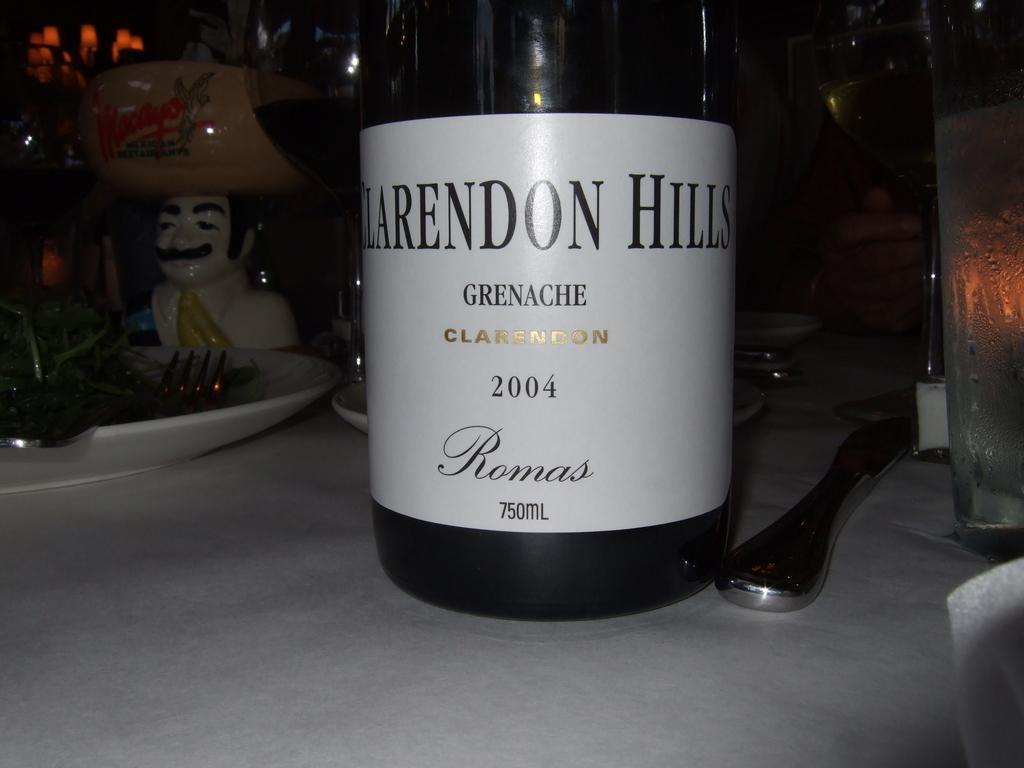Please provide a concise description of this image. In this image we can see bottles, plates, knife, forks and a toy on the table, also the background is dark. 